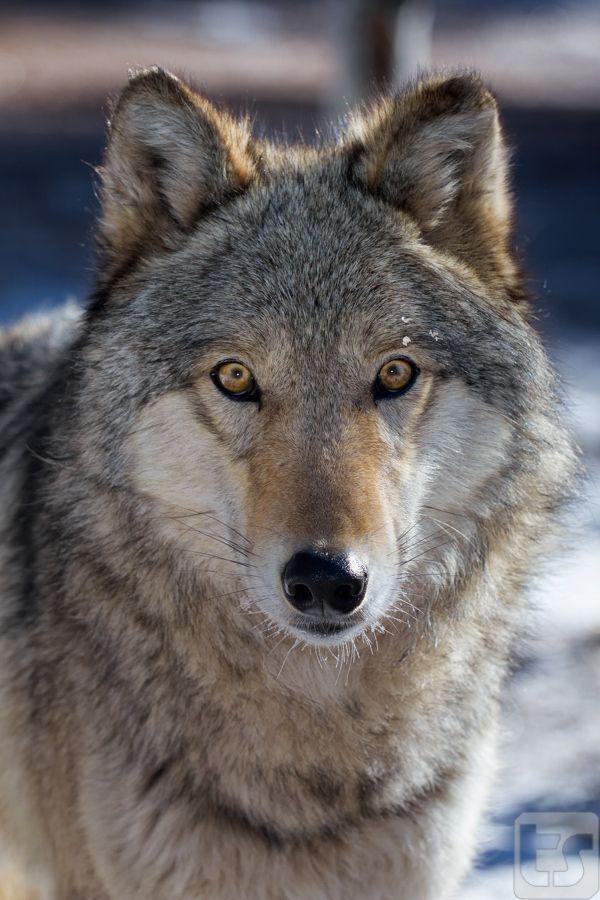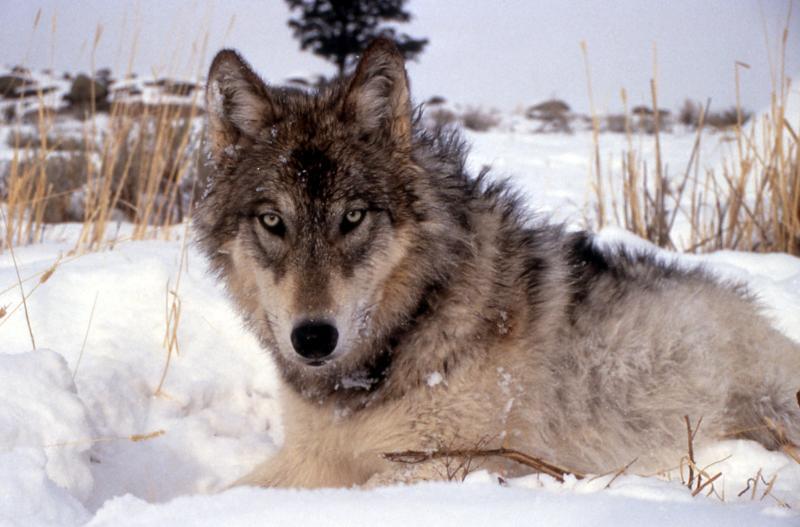The first image is the image on the left, the second image is the image on the right. Evaluate the accuracy of this statement regarding the images: "the wolf on the right image is sitting". Is it true? Answer yes or no. Yes. 